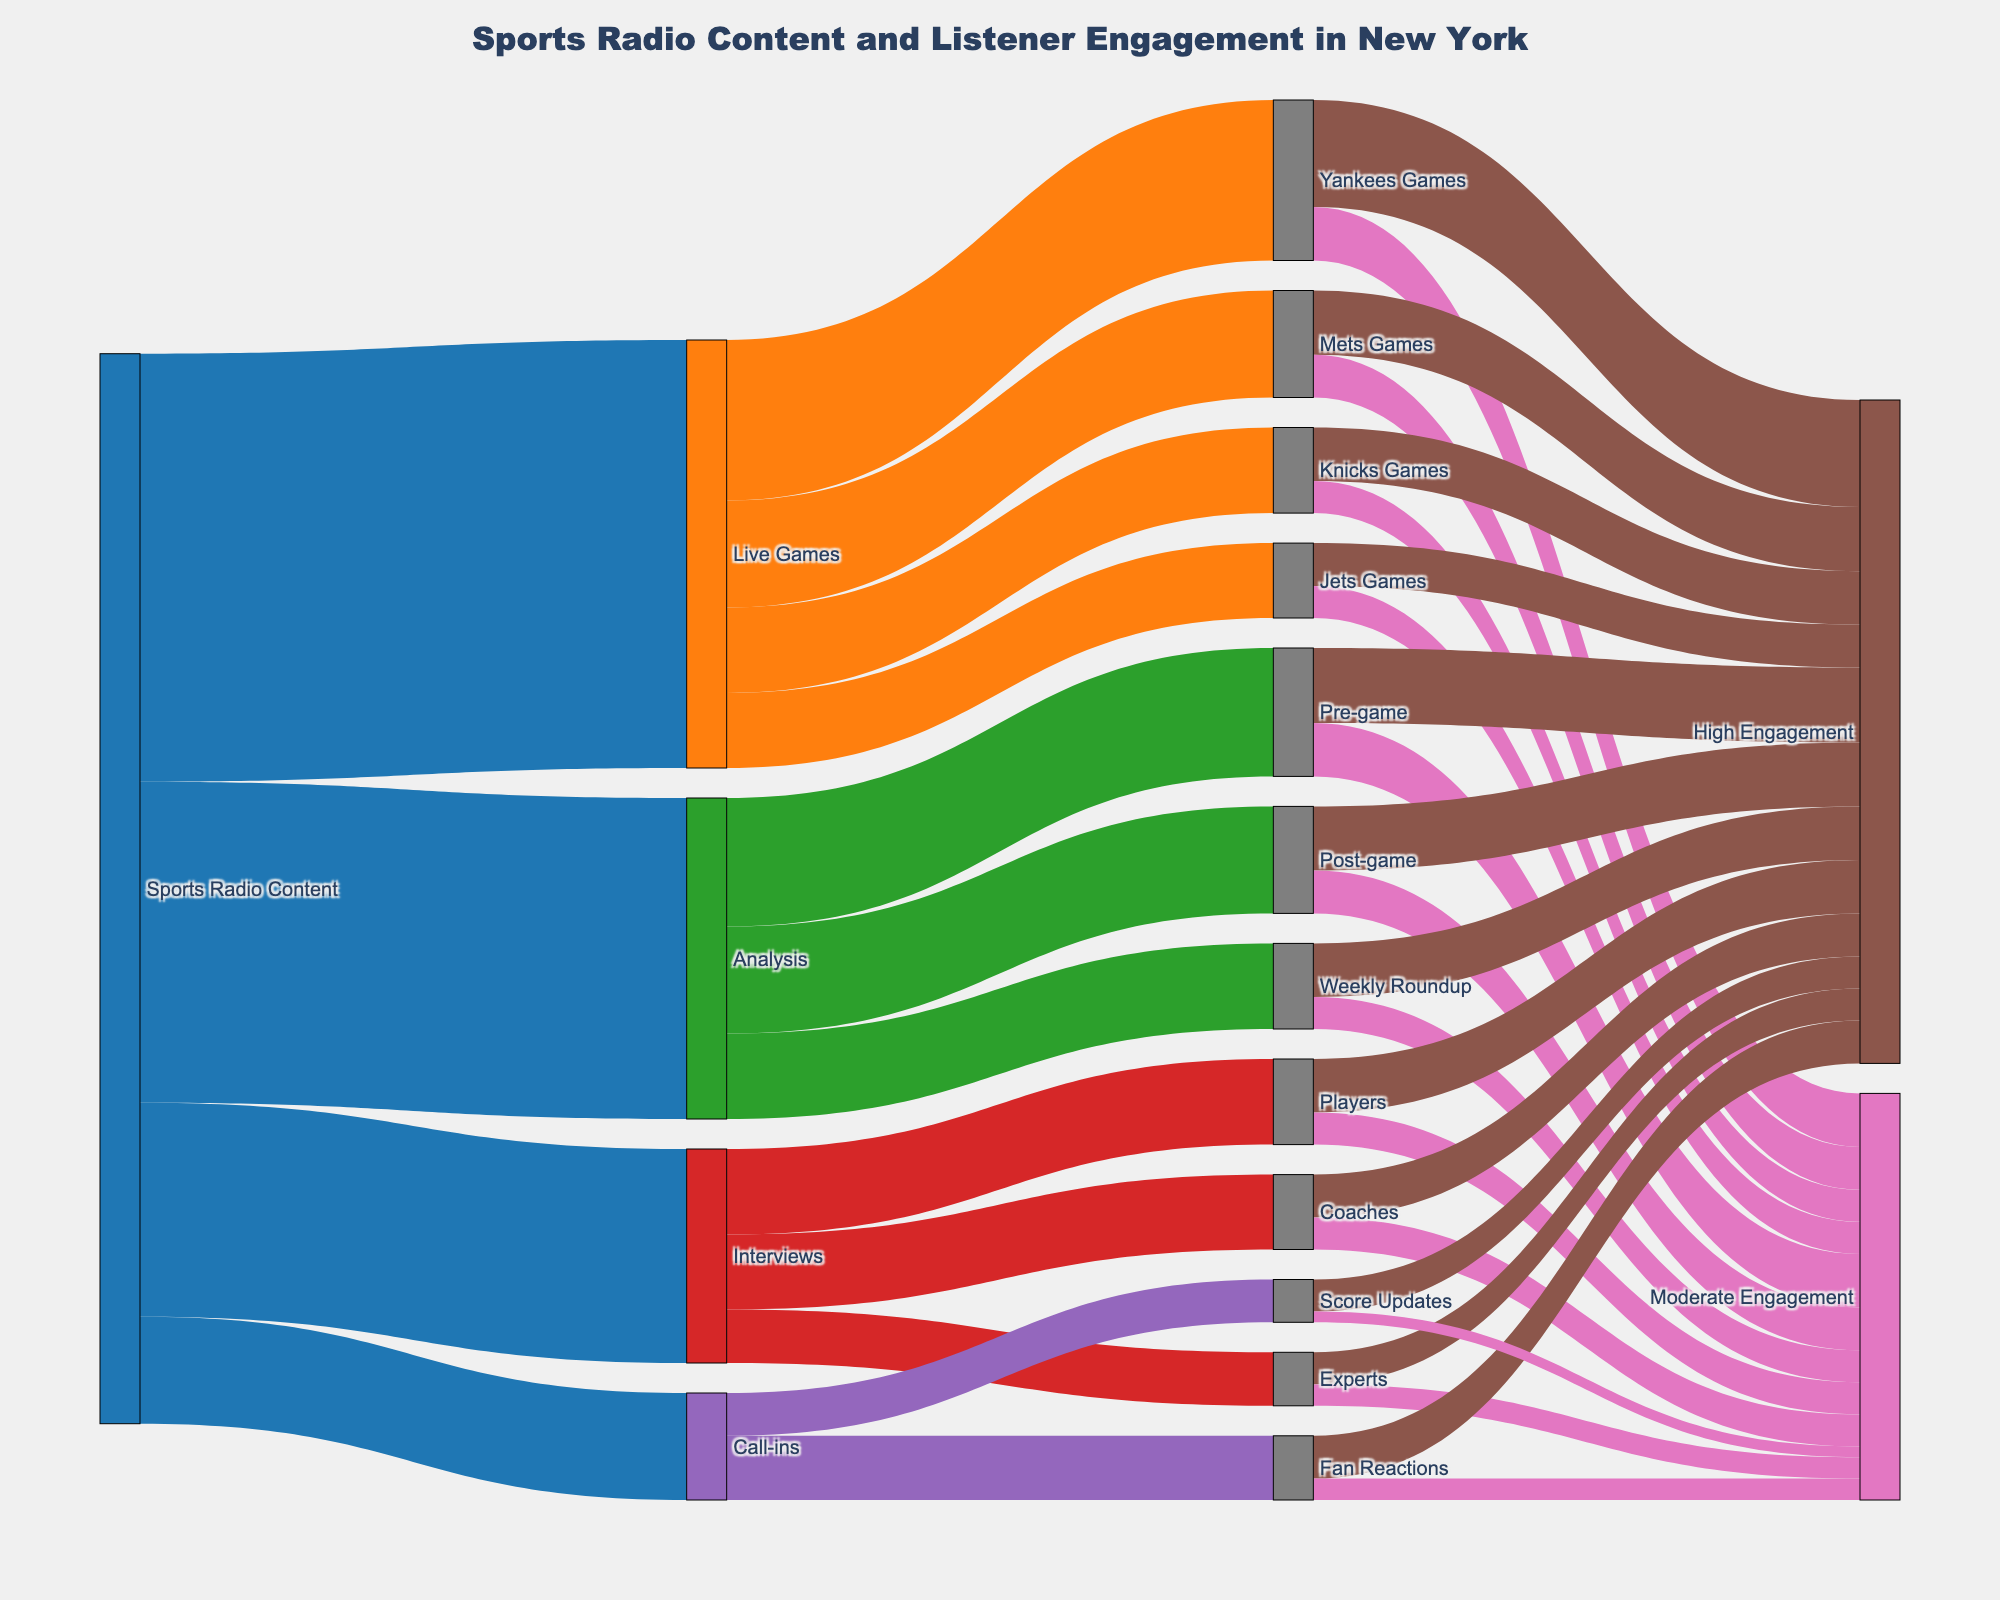How much content is dedicated to live games? The link labeled "Sports Radio Content" flows into "Live Games" with a value indicating the amount of content dedicated to live games. This amount is stated as 40.
Answer: 40 Which type of live game has the highest listener engagement? Follow the flow from "Live Games" and then check which sub-category ("Yankees Games", "Mets Games", "Knicks Games", "Jets Games") has the highest value for "High Engagement". The "Yankees Games" have the highest high engagement value of 10.
Answer: Yankees Games What type of analysis content has the highest engagement? Trace the flow from "Analysis" to its sub-categories: "Pre-game", "Post-game", "Weekly Roundup". Then look at their respective engagement levels. "Pre-game" has the highest "High Engagement" value of 7.
Answer: Pre-game How does the engagement in Mets games compare to Knicks games? Follow the links from "Mets Games" and "Knicks Games" to their respective "High Engagement" and "Moderate Engagement" values. Mets games have 6 (High) and 4 (Moderate) compared to Knicks games with 5 (High) and 3 (Moderate), showing that Mets games have higher engagement overall.
Answer: Mets games have higher engagement Which interview type has the lowest engagement? Follow the link from "Interviews" to its sub-categories: "Players", "Coaches", "Experts". Then check their respective engagement values. "Experts" have the lowest combined value with 3 for "High Engagement" and 2 for "Moderate Engagement".
Answer: Experts What's the total engagement for Jets games? Add the high and moderate engagement values for "Jets Games". High engagement is 4 and moderate engagement is 3. Therefore, total engagement is 4 + 3.
Answer: 7 Compare the total listener engagement between call-ins and interviews. Trace the flow for "Call-ins" and "Interviews" to their respective high and moderate engagement values. Add up these values: Call-ins total (4 + 2) + (3 + 1) = 10 and Interviews total (5 + 3) + (4 + 3) + (3 + 2) = 20.
Answer: Interviews have higher total engagement Among the sports teams, which one has the lowest moderate engagement? Trace the flow from the various sports teams ("Yankees Games", "Mets Games", "Knicks Games", "Jets Games") to moderate engagement. "Jets Games" have the lowest moderate engagement value with 3.
Answer: Jets Games 